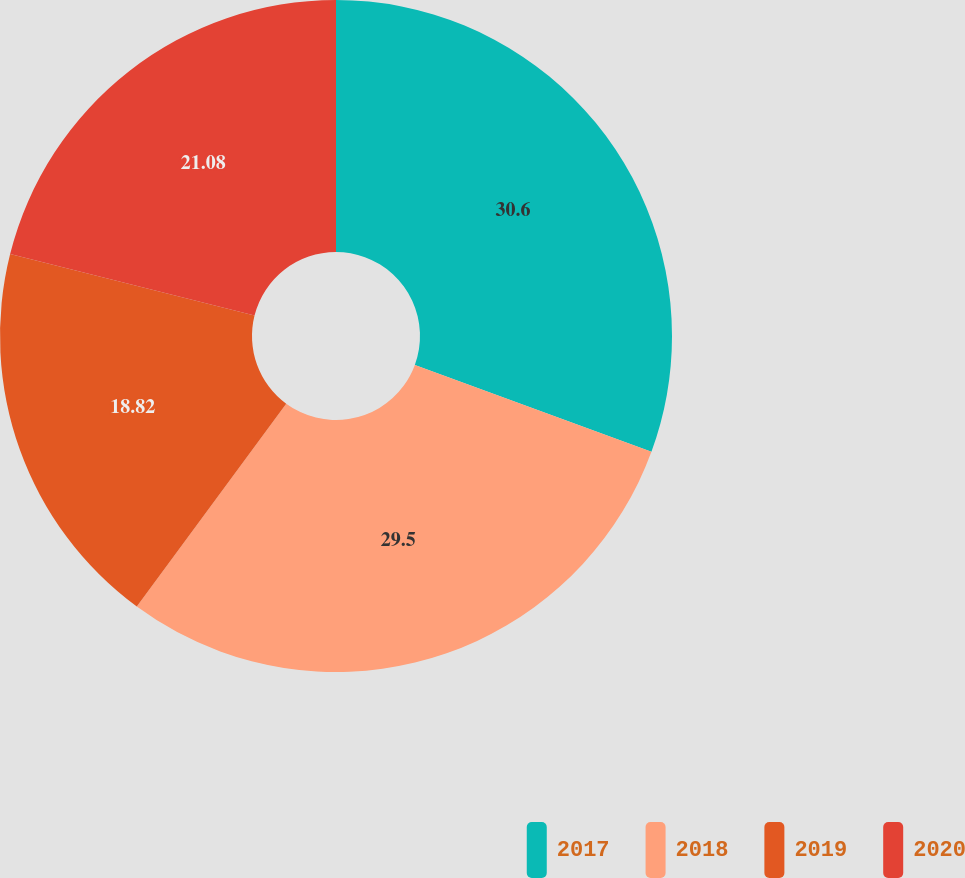<chart> <loc_0><loc_0><loc_500><loc_500><pie_chart><fcel>2017<fcel>2018<fcel>2019<fcel>2020<nl><fcel>30.6%<fcel>29.5%<fcel>18.82%<fcel>21.08%<nl></chart> 